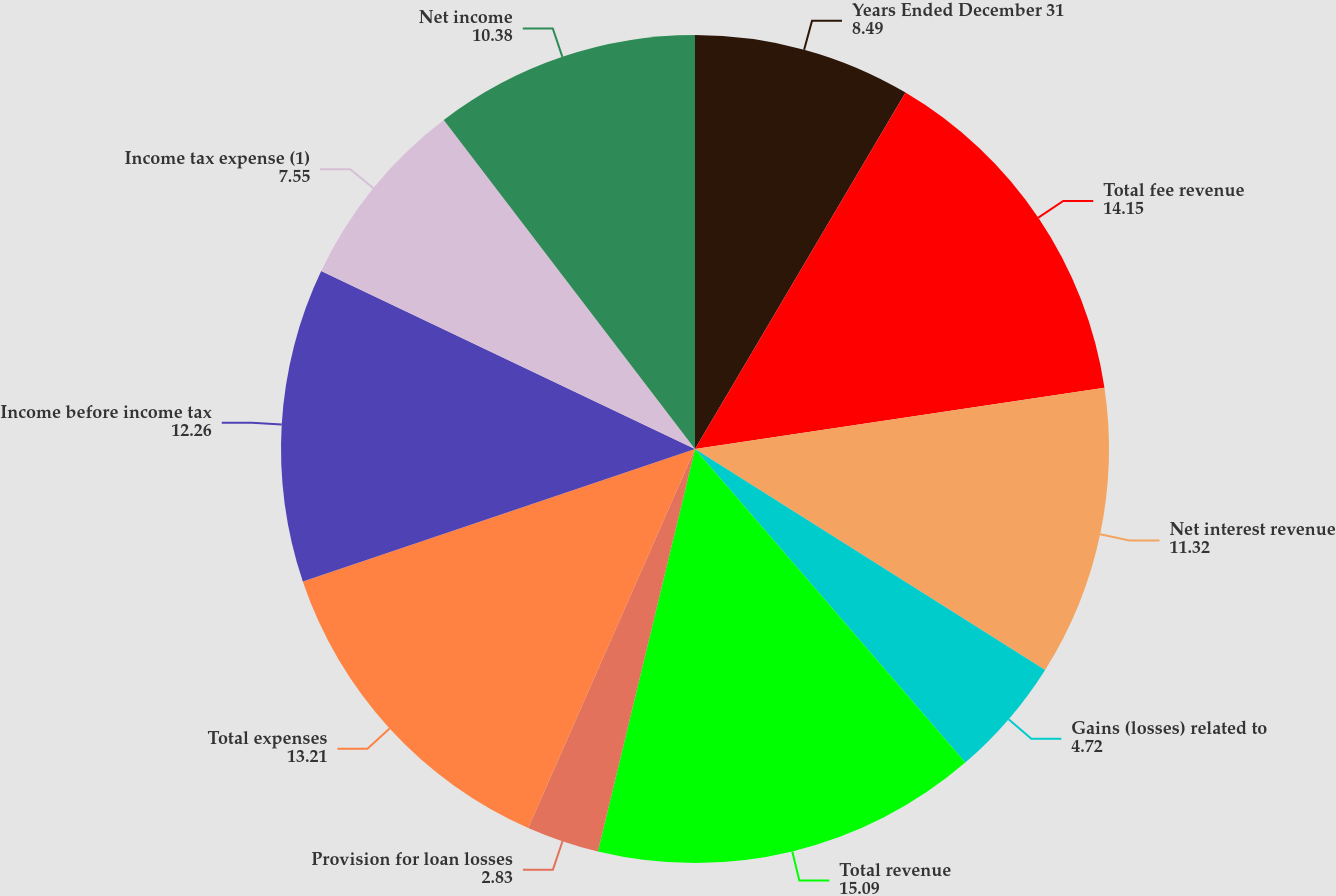Convert chart. <chart><loc_0><loc_0><loc_500><loc_500><pie_chart><fcel>Years Ended December 31<fcel>Total fee revenue<fcel>Net interest revenue<fcel>Gains (losses) related to<fcel>Total revenue<fcel>Provision for loan losses<fcel>Total expenses<fcel>Income before income tax<fcel>Income tax expense (1)<fcel>Net income<nl><fcel>8.49%<fcel>14.15%<fcel>11.32%<fcel>4.72%<fcel>15.09%<fcel>2.83%<fcel>13.21%<fcel>12.26%<fcel>7.55%<fcel>10.38%<nl></chart> 